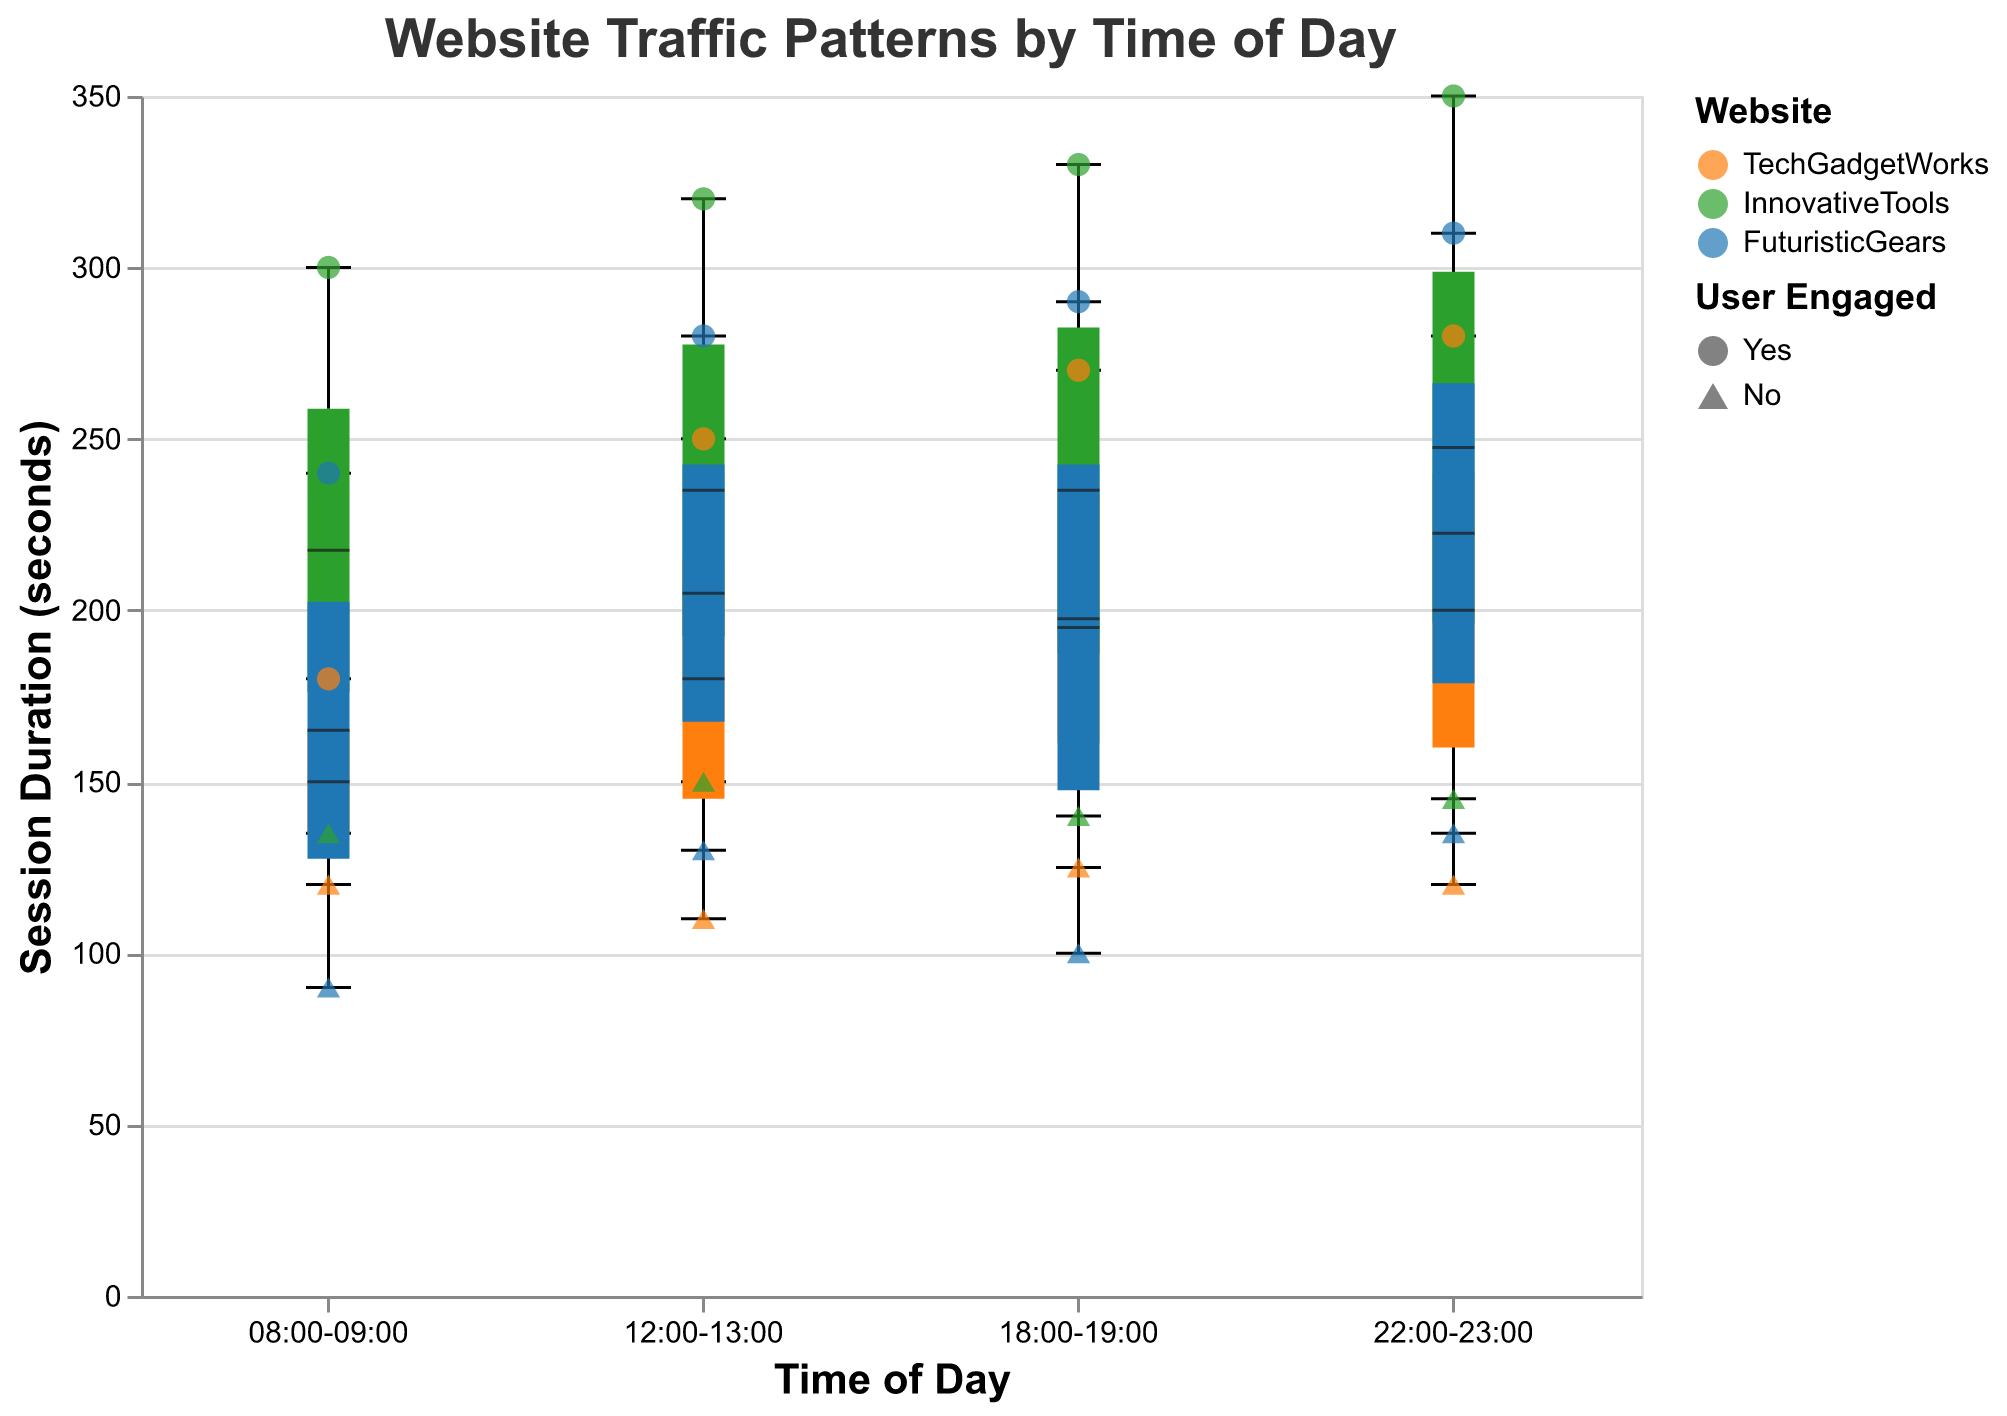What is the title of the figure? The title is typically displayed at the top of the figure. In this case, it is "Website Traffic Patterns by Time of Day."
Answer: Website Traffic Patterns by Time of Day What is the color used for the "FuturisticGears" website in the figure? The legend on the figure indicates that the color associated with "FuturisticGears" is blue.
Answer: Blue How many time periods are displayed on the x-axis? The x-axis shows four distinct time periods: 08:00-09:00, 12:00-13:00, 18:00-19:00, and 22:00-23:00.
Answer: 4 Which website has the highest session duration during the 22:00-23:00 period? By examining the box plots and scatter points, the highest session duration for the 22:00-23:00 period belongs to "InnovativeTools."
Answer: InnovativeTools What shape represents an engaged user? According to the legend, an engaged user is represented by a circle, while a non-engaged user is a triangle-up.
Answer: Circle Which time period shows the largest variation in session duration for "TechGadgetWorks"? The box plot for "TechGadgetWorks" with the largest vertical span indicates the highest variation. The 22:00-23:00 period shows the widest range.
Answer: 22:00-23:00 What is the range of session duration for "InnovativeTools" during the 12:00-13:00 period? The box plot's whisker range indicates the min and max session durations. For "InnovativeTools" during 12:00-13:00, the range is from 150 seconds to 320 seconds.
Answer: 150 to 320 seconds Compare the median session duration between "TechGadgetWorks" and "FuturisticGears" during the 18:00-19:00 period. Which one is higher? The box plot's central line represents the median. "TechGadgetWorks" has a higher median session duration compared to "FuturisticGears" during 18:00-19:00.
Answer: TechGadgetWorks What is the average session duration for engaged users across all websites in the 08:00-09:00 time period? Add the session durations of engaged users for each website during this period (180 + 300 + 240) and divide by the number of engaged users (3), resulting in an average of (180 + 300 + 240) / 3 = 240 seconds.
Answer: 240 seconds 